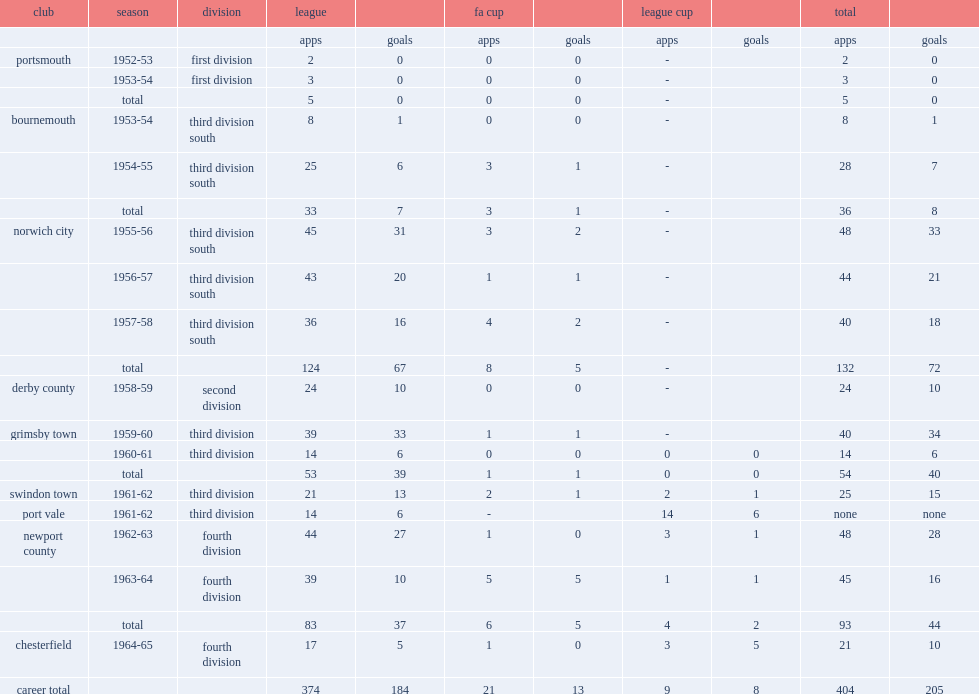In the 1952-53 season, which division did hunt play for club portsmouth? First division. 